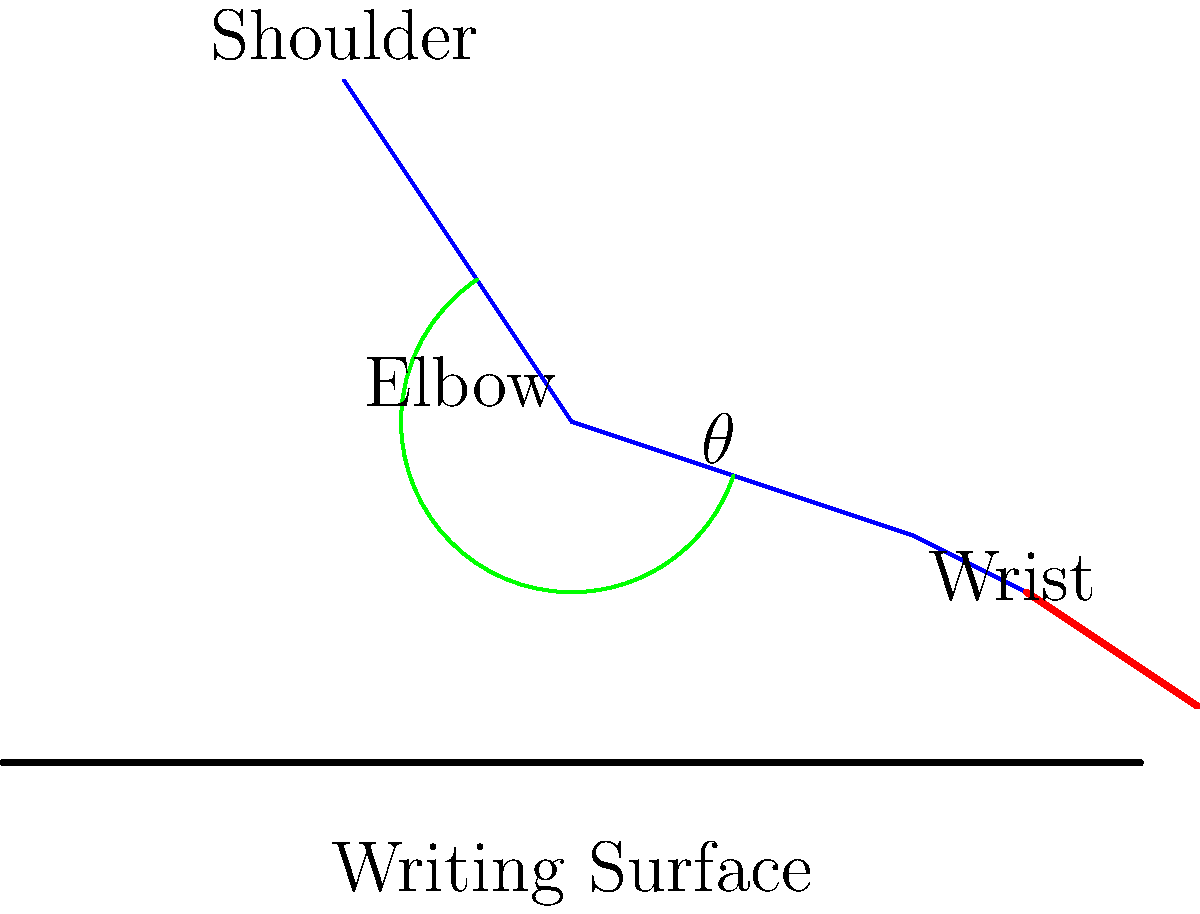Based on the diagram of an ancient scribe's writing posture, which aspect of the arm positioning would likely contribute most to long-term scribal health issues, and how might this inform our understanding of the production of biblical texts? To answer this question, we need to consider several factors:

1. Arm positioning: The diagram shows a bent elbow ($\theta$) and a downward-angled wrist.

2. Ergonomic principles: Prolonged awkward postures can lead to musculoskeletal disorders.

3. Ancient writing practices: Scribes often worked for long hours on a daily basis.

4. Impact on biblical text production:
   a) Speed and accuracy of writing
   b) Potential errors due to discomfort
   c) Longevity of scribal careers

5. Analysis of the posture:
   - The shoulder appears to be in a neutral position.
   - The elbow angle ($\theta$) seems reasonable, allowing for a balanced position.
   - The wrist shows a significant downward angle, which is concerning from an ergonomic perspective.

6. Wrist positioning:
   - The bent wrist posture can lead to compression of the median nerve.
   - This may result in conditions like carpal tunnel syndrome.
   - Such issues could affect the scribe's ability to write accurately and for extended periods.

7. Implications for biblical scholarship:
   - Understanding these ergonomic challenges can inform our analysis of scribal variations and errors in biblical texts.
   - It may provide insights into the working conditions and practices of ancient scribes.
   - This knowledge can contribute to our form-critical and redaction-critical approaches by considering the physical constraints of text production.

Therefore, the wrist positioning is likely the most problematic aspect for long-term scribal health, potentially affecting the quality and quantity of biblical text production.
Answer: Wrist positioning, affecting scribal longevity and text accuracy 